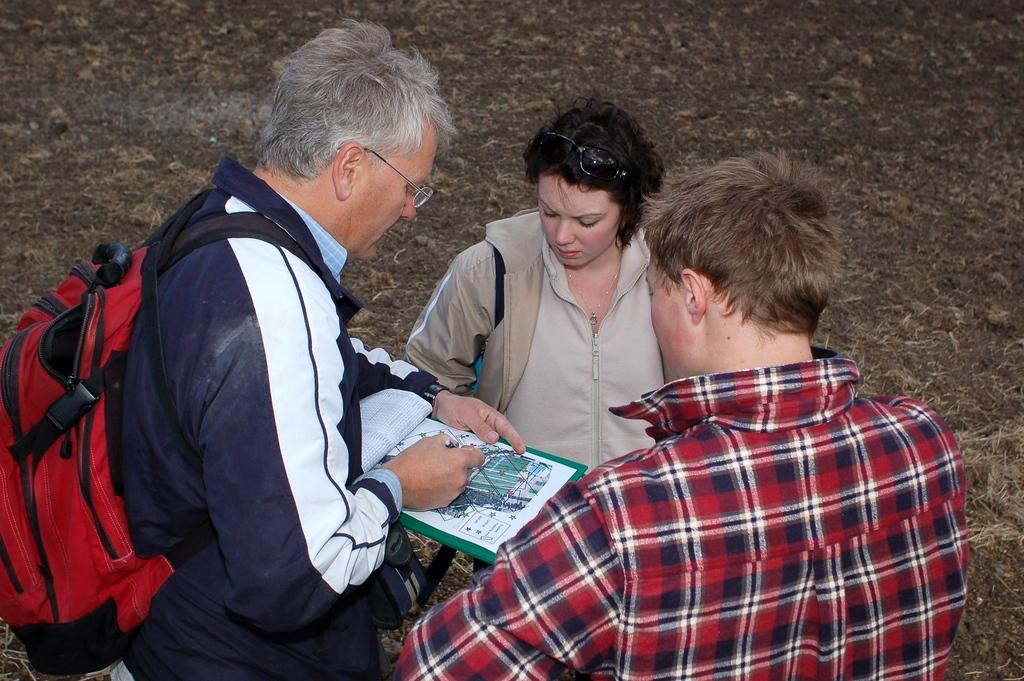How many people are in the image? There are people in the image. Can you describe any specific details about one of the people? One person is wearing a backpack. What might the person with the backpack be carrying in their hand? The person with the backpack is holding objects in their hand. What type of pets are visible in the image? There are no pets visible in the image. Can you describe the needle used by the person in the image? There is no needle present in the image. 